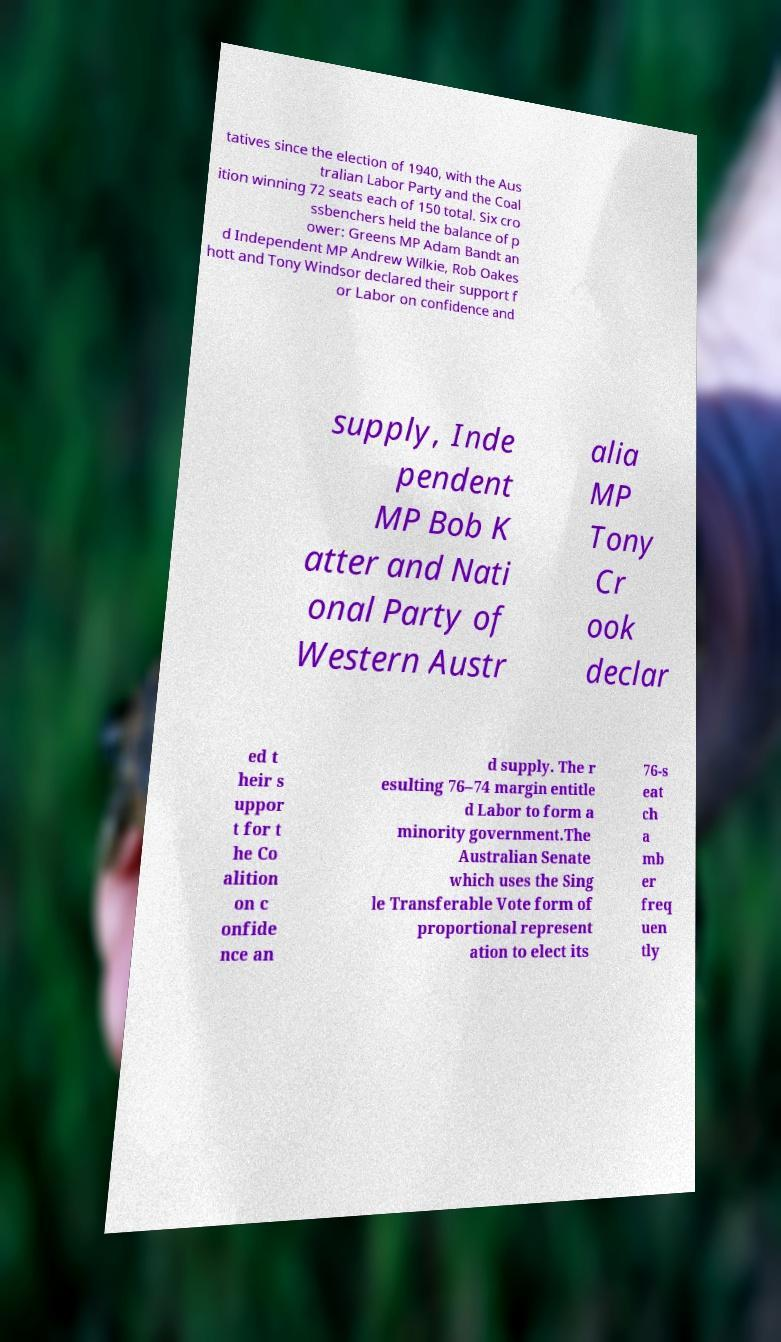Please identify and transcribe the text found in this image. tatives since the election of 1940, with the Aus tralian Labor Party and the Coal ition winning 72 seats each of 150 total. Six cro ssbenchers held the balance of p ower: Greens MP Adam Bandt an d Independent MP Andrew Wilkie, Rob Oakes hott and Tony Windsor declared their support f or Labor on confidence and supply, Inde pendent MP Bob K atter and Nati onal Party of Western Austr alia MP Tony Cr ook declar ed t heir s uppor t for t he Co alition on c onfide nce an d supply. The r esulting 76–74 margin entitle d Labor to form a minority government.The Australian Senate which uses the Sing le Transferable Vote form of proportional represent ation to elect its 76-s eat ch a mb er freq uen tly 